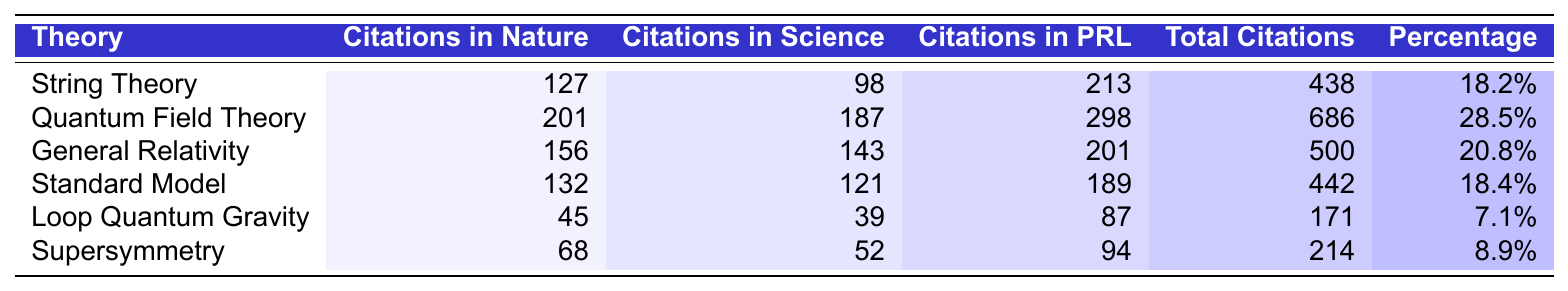What is the total number of citations for Quantum Field Theory? Referring to the table, Quantum Field Theory has a total of 686 citations listed in the "Total Citations" column.
Answer: 686 Which theory has the highest number of citations in Science? The table shows that Quantum Field Theory has the highest number of citations in Science, with 187 citations listed under that column.
Answer: Quantum Field Theory What is the difference in total citations between String Theory and General Relativity? To find the difference, subtract the total citations of String Theory (438) from General Relativity (500): 500 - 438 = 62.
Answer: 62 Is the percentage of total citations for Supersymmetry greater than that for Loop Quantum Gravity? The table indicates that Supersymmetry has 8.9% while Loop Quantum Gravity has 7.1%. Therefore, 8.9% is greater than 7.1%.
Answer: Yes What is the average percentage of total citations for all listed theories? To find the average, sum the percentages: 18.2 + 28.5 + 20.8 + 18.4 + 7.1 + 8.9 = 101.9, and then divide by the number of theories, which is 6: 101.9 / 6 ≈ 16.98.
Answer: 16.98% Which theory has the lowest percentage of total citations? By examining the "Percentage of Total" column, Loop Quantum Gravity has the lowest percentage at 7.1%.
Answer: Loop Quantum Gravity What is the total number of citations for theories that have a percentage greater than 20%? The applicable theories with percentage greater than 20% are Quantum Field Theory (686) and General Relativity (500). So, the total is: 686 + 500 = 1186.
Answer: 1186 How many citations in Nature does String Theory have compared to Supersymmetry? The citations in Nature for String Theory are 127 and for Supersymmetry are 68. Therefore, String Theory has 127 - 68 = 59 more citations in Nature than Supersymmetry.
Answer: 59 Which theory is closest to the overall average of total citations across all theories? The overall average is 438 (calculated by summing total citations and dividing by the number of theories). The numbers closest to this average are String Theory (438) and Standard Model (442).
Answer: String Theory and Standard Model Is the sum of citations in Nature for all theories less than 800? Summing the Nature citations: 127 + 201 + 156 + 132 + 45 + 68 = 729. Since 729 is less than 800, the answer is yes.
Answer: Yes 